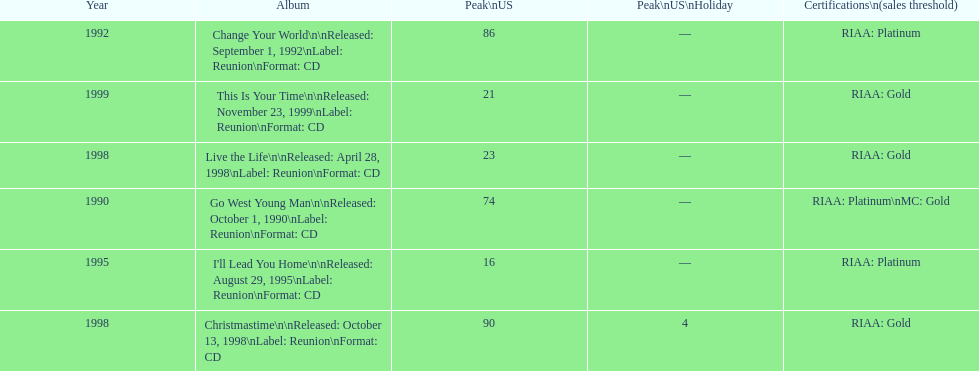What is the number of michael w smith albums that made it to the top 25 of the charts? 3. 